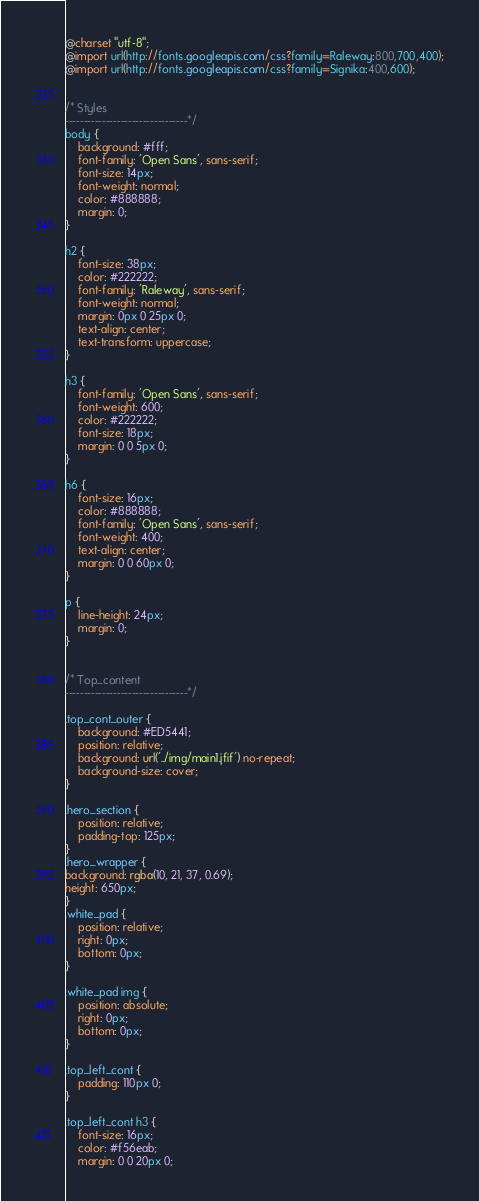Convert code to text. <code><loc_0><loc_0><loc_500><loc_500><_CSS_>

@charset "utf-8";
@import url(http://fonts.googleapis.com/css?family=Raleway:800,700,400);
@import url(http://fonts.googleapis.com/css?family=Signika:400,600);


/* Styles
---------------------------------*/
body {
    background: #fff;
    font-family: 'Open Sans', sans-serif;
    font-size: 14px;
    font-weight: normal;
    color: #888888;
    margin: 0;
}

h2 {
    font-size: 38px;
    color: #222222;
    font-family: 'Raleway', sans-serif;
    font-weight: normal;
    margin: 0px 0 25px 0;
    text-align: center;
    text-transform: uppercase;
}

h3 {
    font-family: 'Open Sans', sans-serif;
    font-weight: 600;
    color: #222222;
    font-size: 18px;
    margin: 0 0 5px 0;
}

h6 {
    font-size: 16px;
    color: #888888;
    font-family: 'Open Sans', sans-serif;
    font-weight: 400;
    text-align: center;
    margin: 0 0 60px 0;
}

p {
    line-height: 24px;
    margin: 0;
}


/* Top_content
---------------------------------*/

.top_cont_outer {
    background: #ED5441;
    position: relative;
    background: url('../img/main1.jfif') no-repeat;
	background-size: cover;
}

.hero_section {
    position: relative;
    padding-top: 125px;
}
.hero_wrapper {
background: rgba(10, 21, 37, 0.69);
height: 650px;
}
.white_pad {
    position: relative;
    right: 0px;
    bottom: 0px;
}

.white_pad img {
    position: absolute;
    right: 0px;
    bottom: 0px;
}

.top_left_cont {
    padding: 110px 0;
}

.top_left_cont h3 {
    font-size: 16px;
    color: #f56eab;
    margin: 0 0 20px 0;</code> 